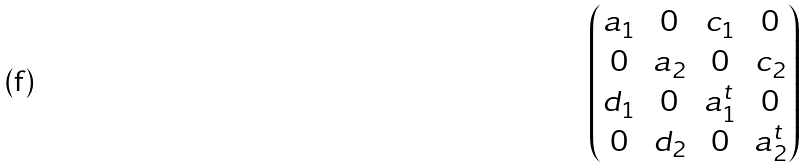<formula> <loc_0><loc_0><loc_500><loc_500>\begin{pmatrix} a _ { 1 } & 0 & c _ { 1 } & 0 \\ 0 & a _ { 2 } & 0 & c _ { 2 } \\ d _ { 1 } & 0 & a _ { 1 } ^ { t } & 0 \\ 0 & d _ { 2 } & 0 & a _ { 2 } ^ { t } \end{pmatrix}</formula> 